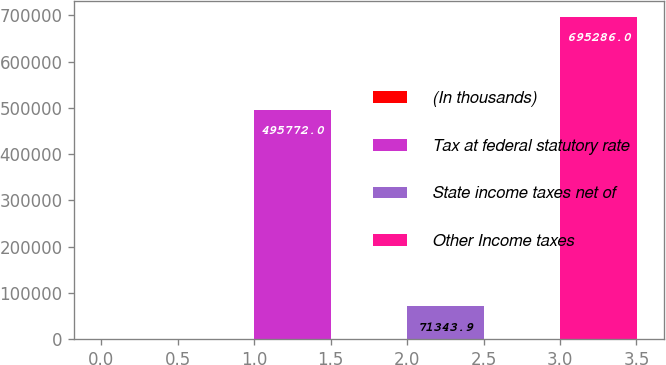Convert chart to OTSL. <chart><loc_0><loc_0><loc_500><loc_500><bar_chart><fcel>(In thousands)<fcel>Tax at federal statutory rate<fcel>State income taxes net of<fcel>Other Income taxes<nl><fcel>2017<fcel>495772<fcel>71343.9<fcel>695286<nl></chart> 